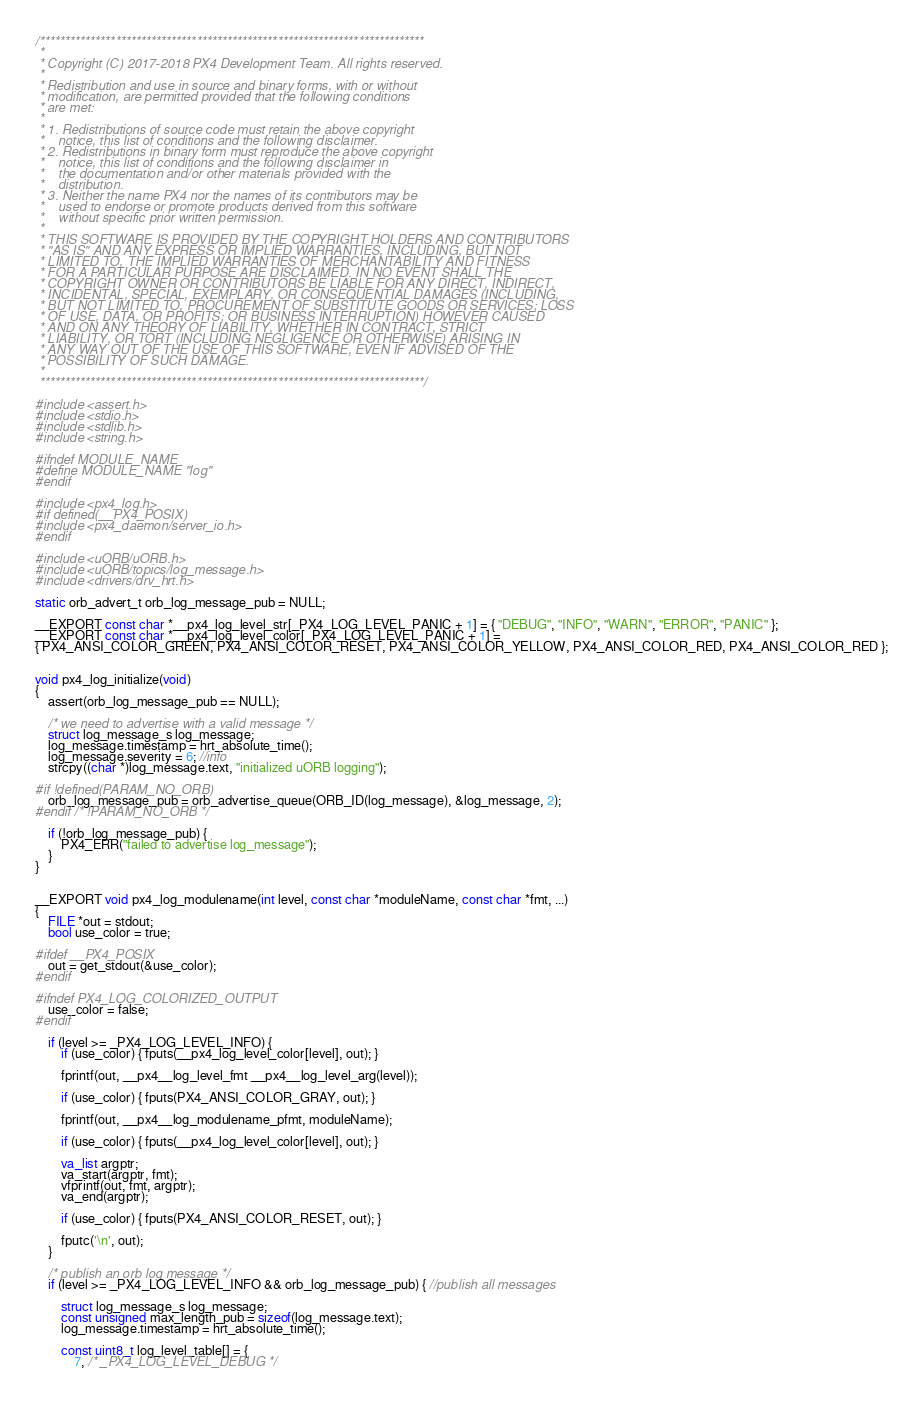Convert code to text. <code><loc_0><loc_0><loc_500><loc_500><_C_>/****************************************************************************
 *
 * Copyright (C) 2017-2018 PX4 Development Team. All rights reserved.
 *
 * Redistribution and use in source and binary forms, with or without
 * modification, are permitted provided that the following conditions
 * are met:
 *
 * 1. Redistributions of source code must retain the above copyright
 *    notice, this list of conditions and the following disclaimer.
 * 2. Redistributions in binary form must reproduce the above copyright
 *    notice, this list of conditions and the following disclaimer in
 *    the documentation and/or other materials provided with the
 *    distribution.
 * 3. Neither the name PX4 nor the names of its contributors may be
 *    used to endorse or promote products derived from this software
 *    without specific prior written permission.
 *
 * THIS SOFTWARE IS PROVIDED BY THE COPYRIGHT HOLDERS AND CONTRIBUTORS
 * "AS IS" AND ANY EXPRESS OR IMPLIED WARRANTIES, INCLUDING, BUT NOT
 * LIMITED TO, THE IMPLIED WARRANTIES OF MERCHANTABILITY AND FITNESS
 * FOR A PARTICULAR PURPOSE ARE DISCLAIMED. IN NO EVENT SHALL THE
 * COPYRIGHT OWNER OR CONTRIBUTORS BE LIABLE FOR ANY DIRECT, INDIRECT,
 * INCIDENTAL, SPECIAL, EXEMPLARY, OR CONSEQUENTIAL DAMAGES (INCLUDING,
 * BUT NOT LIMITED TO, PROCUREMENT OF SUBSTITUTE GOODS OR SERVICES; LOSS
 * OF USE, DATA, OR PROFITS; OR BUSINESS INTERRUPTION) HOWEVER CAUSED
 * AND ON ANY THEORY OF LIABILITY, WHETHER IN CONTRACT, STRICT
 * LIABILITY, OR TORT (INCLUDING NEGLIGENCE OR OTHERWISE) ARISING IN
 * ANY WAY OUT OF THE USE OF THIS SOFTWARE, EVEN IF ADVISED OF THE
 * POSSIBILITY OF SUCH DAMAGE.
 *
 ****************************************************************************/

#include <assert.h>
#include <stdio.h>
#include <stdlib.h>
#include <string.h>

#ifndef MODULE_NAME
#define MODULE_NAME "log"
#endif

#include <px4_log.h>
#if defined(__PX4_POSIX)
#include <px4_daemon/server_io.h>
#endif

#include <uORB/uORB.h>
#include <uORB/topics/log_message.h>
#include <drivers/drv_hrt.h>

static orb_advert_t orb_log_message_pub = NULL;

__EXPORT const char *__px4_log_level_str[_PX4_LOG_LEVEL_PANIC + 1] = { "DEBUG", "INFO", "WARN", "ERROR", "PANIC" };
__EXPORT const char *__px4_log_level_color[_PX4_LOG_LEVEL_PANIC + 1] =
{ PX4_ANSI_COLOR_GREEN, PX4_ANSI_COLOR_RESET, PX4_ANSI_COLOR_YELLOW, PX4_ANSI_COLOR_RED, PX4_ANSI_COLOR_RED };


void px4_log_initialize(void)
{
	assert(orb_log_message_pub == NULL);

	/* we need to advertise with a valid message */
	struct log_message_s log_message;
	log_message.timestamp = hrt_absolute_time();
	log_message.severity = 6; //info
	strcpy((char *)log_message.text, "initialized uORB logging");

#if !defined(PARAM_NO_ORB)
	orb_log_message_pub = orb_advertise_queue(ORB_ID(log_message), &log_message, 2);
#endif /* !PARAM_NO_ORB */

	if (!orb_log_message_pub) {
		PX4_ERR("failed to advertise log_message");
	}
}


__EXPORT void px4_log_modulename(int level, const char *moduleName, const char *fmt, ...)
{
	FILE *out = stdout;
	bool use_color = true;

#ifdef __PX4_POSIX
	out = get_stdout(&use_color);
#endif

#ifndef PX4_LOG_COLORIZED_OUTPUT
	use_color = false;
#endif

	if (level >= _PX4_LOG_LEVEL_INFO) {
		if (use_color) { fputs(__px4_log_level_color[level], out); }

		fprintf(out, __px4__log_level_fmt __px4__log_level_arg(level));

		if (use_color) { fputs(PX4_ANSI_COLOR_GRAY, out); }

		fprintf(out, __px4__log_modulename_pfmt, moduleName);

		if (use_color) { fputs(__px4_log_level_color[level], out); }

		va_list argptr;
		va_start(argptr, fmt);
		vfprintf(out, fmt, argptr);
		va_end(argptr);

		if (use_color) { fputs(PX4_ANSI_COLOR_RESET, out); }

		fputc('\n', out);
	}

	/* publish an orb log message */
	if (level >= _PX4_LOG_LEVEL_INFO && orb_log_message_pub) { //publish all messages

		struct log_message_s log_message;
		const unsigned max_length_pub = sizeof(log_message.text);
		log_message.timestamp = hrt_absolute_time();

		const uint8_t log_level_table[] = {
			7, /* _PX4_LOG_LEVEL_DEBUG */</code> 